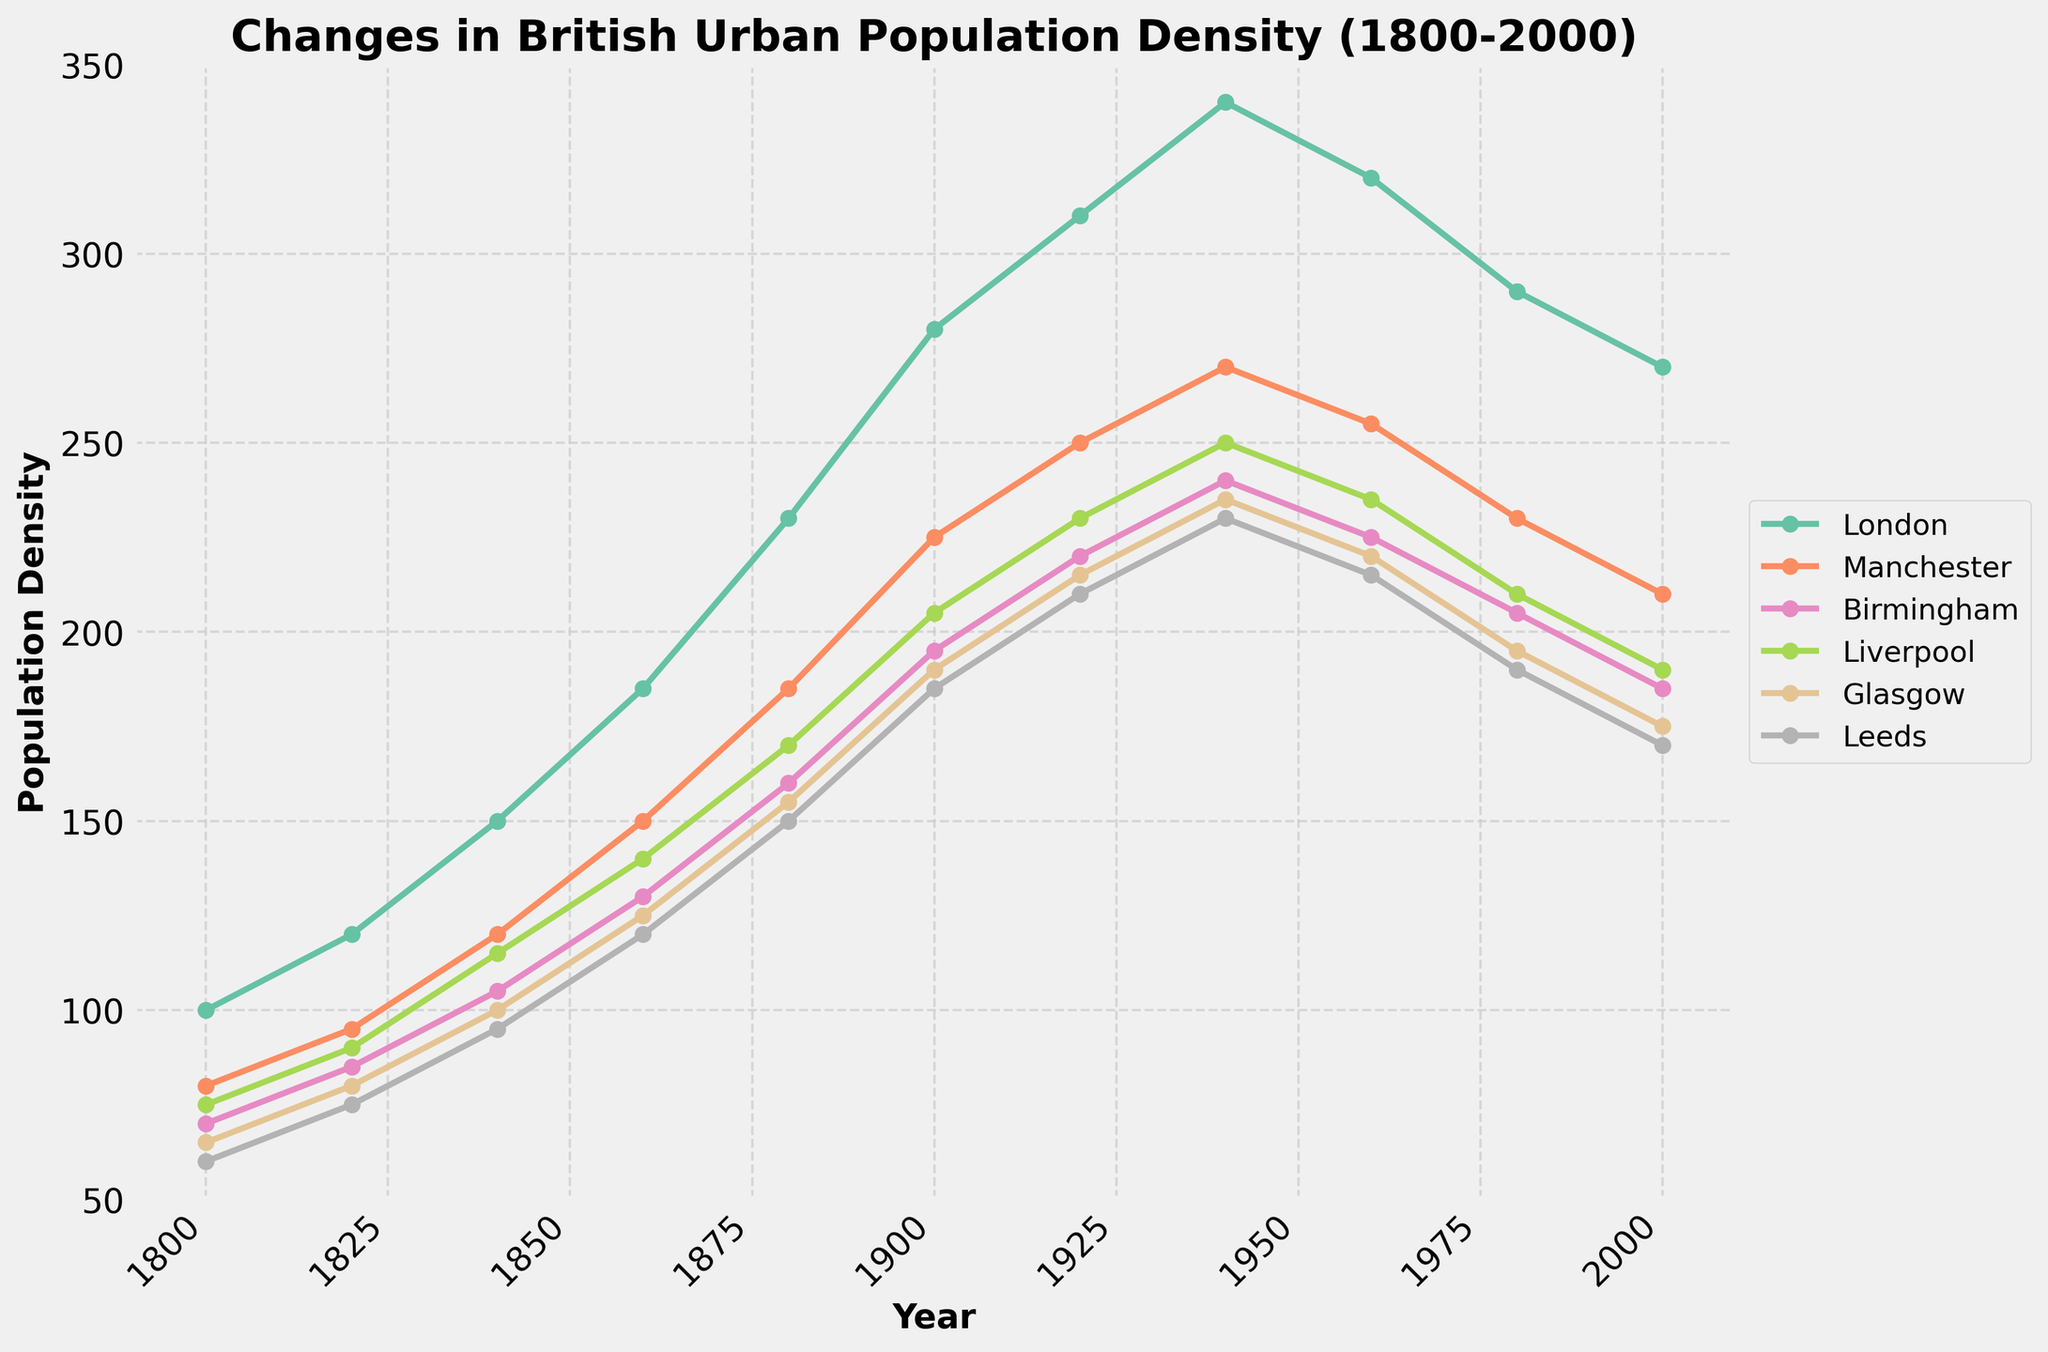How did London's population density change from 1940 to 2000? To find the change in London's population density, look at the data points for London at 1940 and 2000. In 1940, the population density was 340, and in 2000, it was 270. The change is 340 - 270 = 70.
Answer: 70 Which city had the highest population density in 1860? Scan the graph for the year 1860 and compare the population densities of all the cities. London had 185, Manchester 150, Birmingham 130, Liverpool 140, Glasgow 125, and Leeds 120, making London the city with the highest population density that year.
Answer: London Between which consecutive years did Manchester see its greatest increase in population density? Examine Manchester's data points and identify the years where the difference is the greatest. Manchester’s values are: 80 (1800), 95 (1820), 120 (1840), 150 (1860), 185 (1880), 225 (1900), 250 (1920), 270 (1940), 255 (1960), 230 (1980), 210 (2000). The greatest increase was between 1820 (95) and 1840 (120), which is 25.
Answer: 1860-1880 What is the average population density of Glasgow from 1800 to 2000? Sum Glasgow's population densities (65, 80, 100, 125, 155, 190, 215, 235, 220, 195, 175) and divide by the number of data points (11). The sum is 1,755, and the average is 1,755 / 11 = 159.55.
Answer: 159.55 How many cities experienced a decline in population density from 1940 to 2000? Compare the population densities from 1940 to 2000 for each city. London: 340 to 270, Manchester: 270 to 210, Birmingham: 240 to 185, Liverpool: 250 to 190, Glasgow: 235 to 175, Leeds: 230 to 170. All six cities experienced a decline.
Answer: 6 Which city had the smallest population density in 1820 and what was it? Look at the data for 1820 and find the smallest value. For 1820, London: 120, Manchester: 95, Birmingham: 85, Liverpool: 90, Glasgow: 80, Leeds: 75. Leeds had the smallest population density of 75.
Answer: Leeds, 75 What is the median population density of Birmingham over the years? List Birmingham's population densities in ascending order and find the middle value. Birmingham’s values: 70, 85, 105, 130, 160, 195, 220, 240, 225, 205, 185. The middle value (6th one) is 195.
Answer: 195 Which city had the least variation in population density from 1800 to 2000? Calculate the range (max minus min) for each city's population density values. The one with the smallest range is the city with the least variation. Ranges are as follows: London: 280 (340-60), Manchester: 190 (270-80), Birmingham: 175 (240-65), Liverpool: 175 (250-75), Glasgow: 170 (235-65), Leeds: 170 (230-60). Leeds has the least variation of 170.
Answer: Leeds 